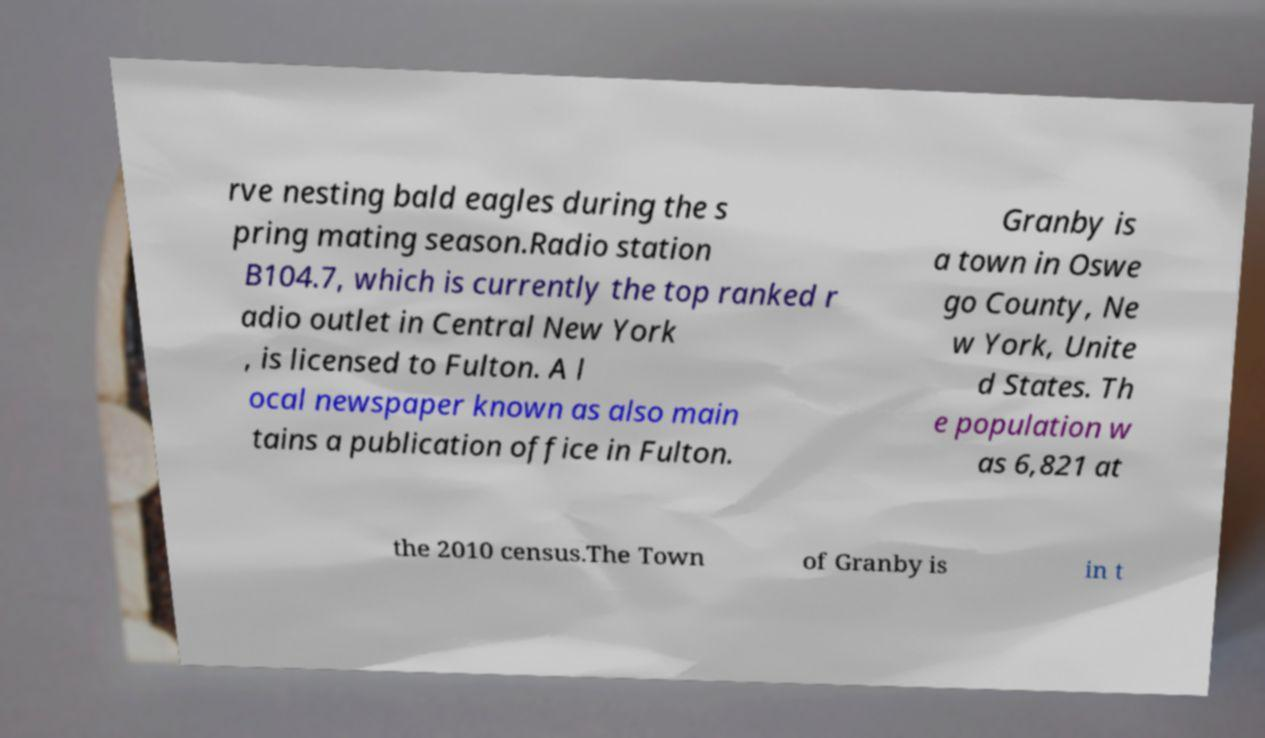Can you read and provide the text displayed in the image?This photo seems to have some interesting text. Can you extract and type it out for me? rve nesting bald eagles during the s pring mating season.Radio station B104.7, which is currently the top ranked r adio outlet in Central New York , is licensed to Fulton. A l ocal newspaper known as also main tains a publication office in Fulton. Granby is a town in Oswe go County, Ne w York, Unite d States. Th e population w as 6,821 at the 2010 census.The Town of Granby is in t 